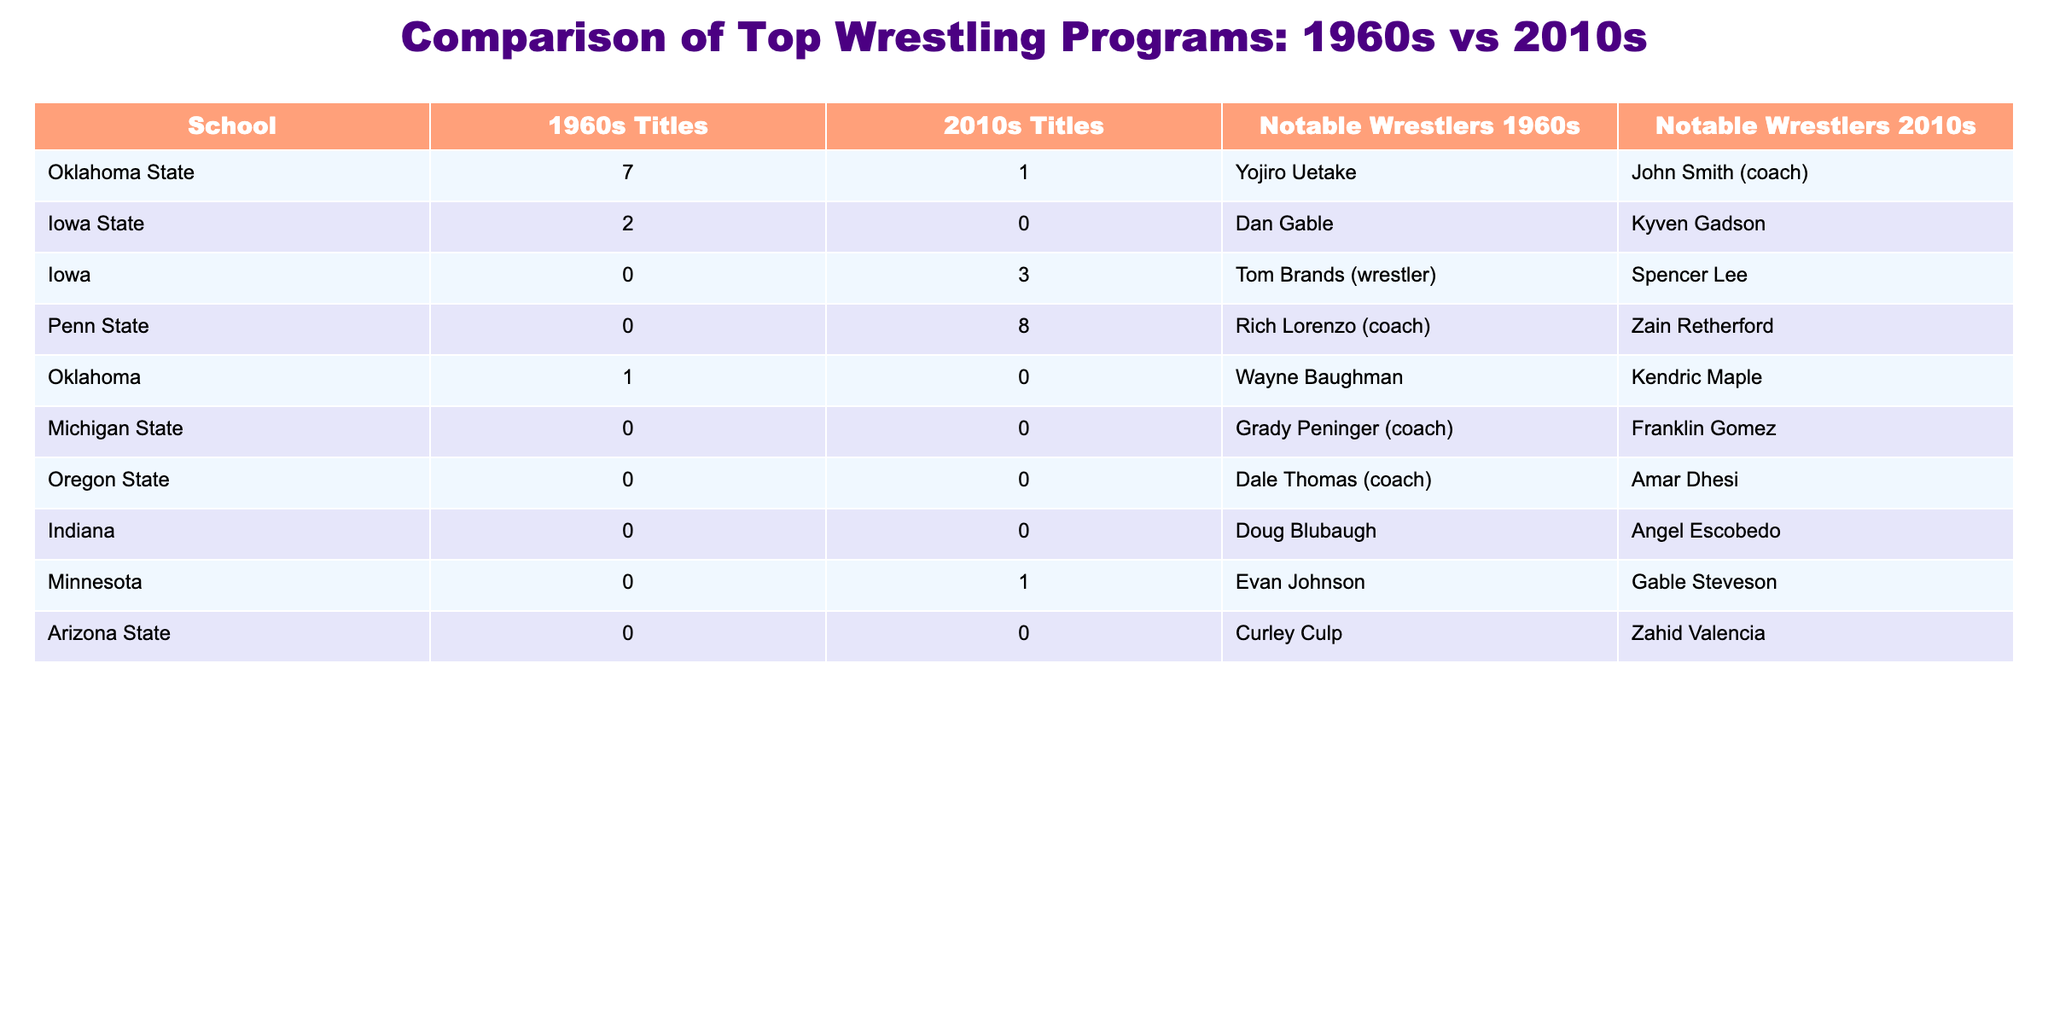What school won the most NCAA wrestling titles in the 1960s? Looking at the 1960s Titles column, Oklahoma State has the highest value of 7 titles, which is greater than all other schools in that decade.
Answer: Oklahoma State How many total NCAA wrestling titles did Oklahoma State win in both decades? Adding the titles from both decades for Oklahoma State gives us 7 (1960s) + 1 (2010s) = 8 titles.
Answer: 8 Which school had notable wrestlers in both the 1960s and 2010s? Reviewing the Notable Wrestlers columns, Oklahoma State is represented in both decades by Yojiro Uetake (1960s) and John Smith (2010s).
Answer: Yes What is the difference in NCAA titles for Iowa State between the two decades? Iowa State won 2 titles in the 1960s and 0 in the 2010s. The difference is 2 - 0 = 2 titles.
Answer: 2 Which school had the most titles in the 2010s and how many? In the 2010s Titles column, Penn State has the highest count with 8 titles, more than any other school.
Answer: Penn State, 8 Is it true that Iowa won more NCAA titles in the 2010s than in the 1960s? Iowa had 0 titles in the 1960s and 3 in the 2010s. Therefore, it is true that they won more titles in the later decade.
Answer: Yes What was the total number of titles won by schools that had notable wrestlers in the 1960s only? Only Oklahoma State and Iowa State had titles in the 1960s, totaling 7 (Oklahoma State) + 2 (Iowa State) = 9 titles.
Answer: 9 Are there any schools that won titles during the 2010s but had none in the 1960s? Yes, Iowa won 3 titles in the 2010s but had none in the 1960s.
Answer: Yes What is the average number of titles won by the listed schools in the 2010s? The total number of titles in the 2010s is 1 + 0 + 3 + 8 + 0 + 0 + 0 + 1 + 0 = 13 titles and there are 9 schools, so the average is 13/9 ≈ 1.44.
Answer: 1.44 